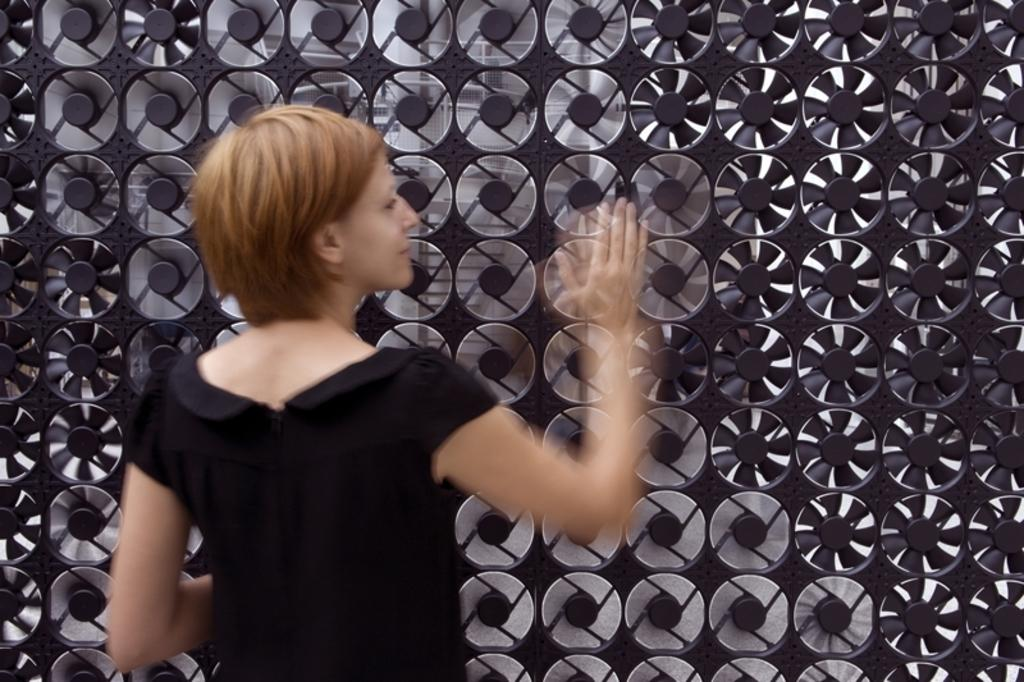Who is the main subject in the image? There is a girl in the image. What is the girl doing in the image? The girl is waving her hand. What other object can be seen in the image? There is a table fan in the image. What type of cheese is being served on the table in the image? There is no cheese present in the image; it only features a girl waving her hand and a table fan. 